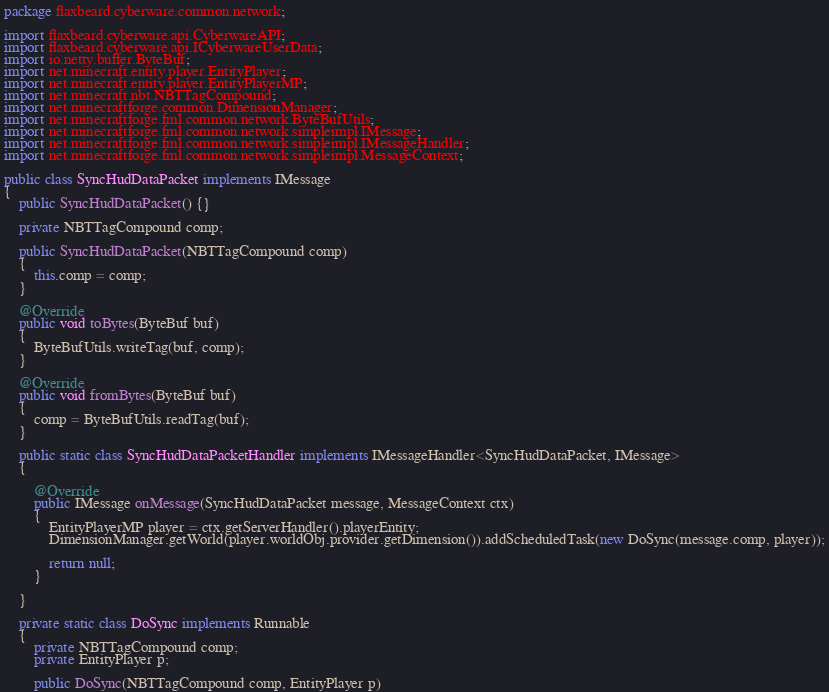<code> <loc_0><loc_0><loc_500><loc_500><_Java_>package flaxbeard.cyberware.common.network;

import flaxbeard.cyberware.api.CyberwareAPI;
import flaxbeard.cyberware.api.ICyberwareUserData;
import io.netty.buffer.ByteBuf;
import net.minecraft.entity.player.EntityPlayer;
import net.minecraft.entity.player.EntityPlayerMP;
import net.minecraft.nbt.NBTTagCompound;
import net.minecraftforge.common.DimensionManager;
import net.minecraftforge.fml.common.network.ByteBufUtils;
import net.minecraftforge.fml.common.network.simpleimpl.IMessage;
import net.minecraftforge.fml.common.network.simpleimpl.IMessageHandler;
import net.minecraftforge.fml.common.network.simpleimpl.MessageContext;

public class SyncHudDataPacket implements IMessage
{
	public SyncHudDataPacket() {}
	
	private NBTTagCompound comp;

	public SyncHudDataPacket(NBTTagCompound comp)
	{
		this.comp = comp;
	}

	@Override
	public void toBytes(ByteBuf buf)
	{
		ByteBufUtils.writeTag(buf, comp);
	}
	
	@Override
	public void fromBytes(ByteBuf buf)
	{
		comp = ByteBufUtils.readTag(buf);
	}
	
	public static class SyncHudDataPacketHandler implements IMessageHandler<SyncHudDataPacket, IMessage>
	{

		@Override
		public IMessage onMessage(SyncHudDataPacket message, MessageContext ctx)
		{
			EntityPlayerMP player = ctx.getServerHandler().playerEntity;
			DimensionManager.getWorld(player.worldObj.provider.getDimension()).addScheduledTask(new DoSync(message.comp, player));

			return null;
		}
		
	}
	
	private static class DoSync implements Runnable
	{
		private NBTTagCompound comp;
		private EntityPlayer p;

		public DoSync(NBTTagCompound comp, EntityPlayer p)</code> 